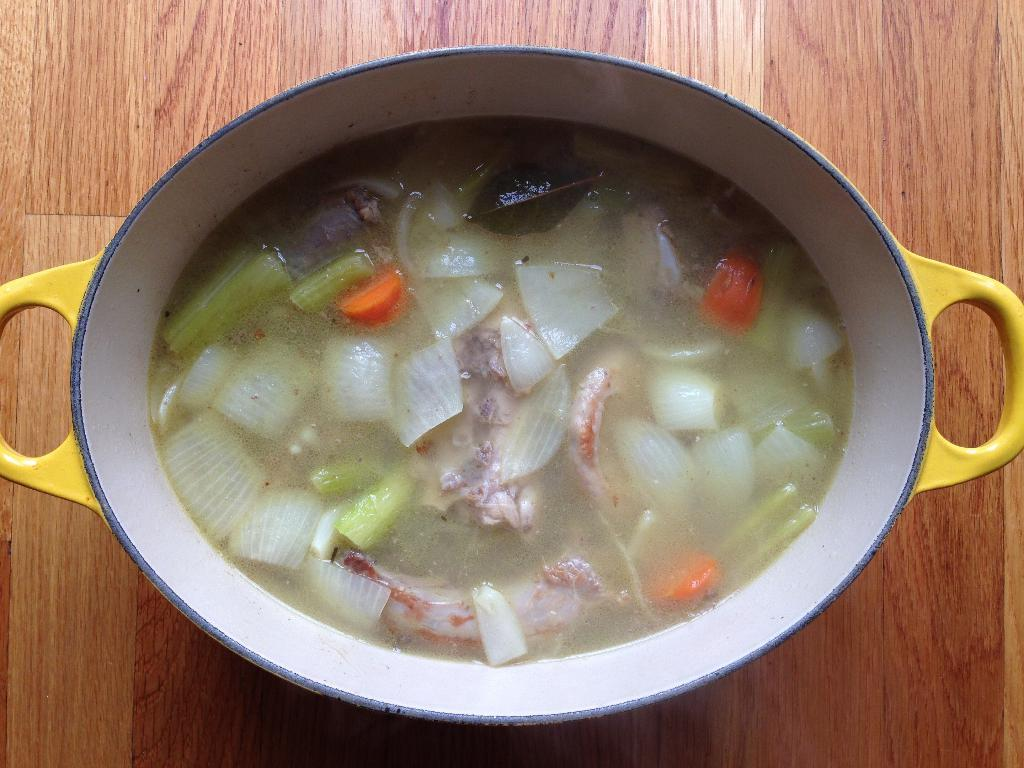What is in the bowl that is visible in the image? The bowl contains soup in the image. What type of surface is the bowl placed on? The wooden surface is present in the image. Where is the bowl located in relation to the wooden surface? The bowl is placed on the wooden surface. How does the visitor twist the hat in the image? There is no visitor or hat present in the image. 